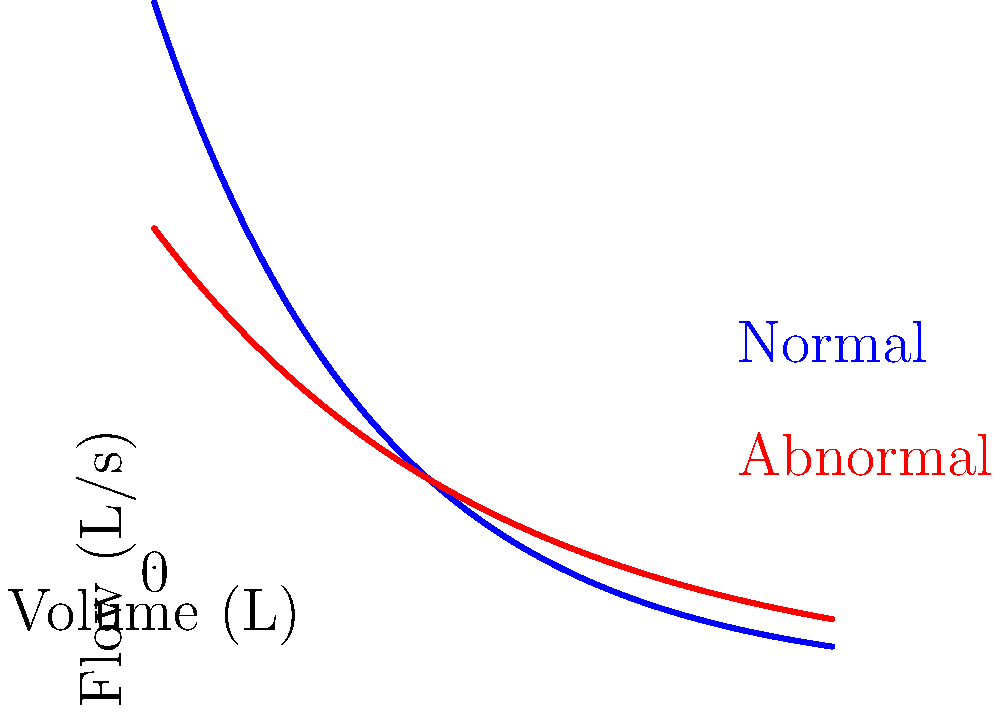Based on the spirometry graph shown, which represents a flow-volume loop for both a normal subject (blue) and a patient with lung dysfunction (red), what type of lung condition does the abnormal curve most likely indicate? To interpret this spirometry graph and identify the likely lung condition:

1. Observe the shape of both curves:
   - The normal curve (blue) shows a rapid rise to peak flow, followed by a steady decline.
   - The abnormal curve (red) shows a lower peak flow and a more gradual decline.

2. Compare the expiratory flow rates:
   - The abnormal curve has lower flow rates throughout expiration.
   - The peak expiratory flow (PEF) is significantly reduced in the abnormal curve.

3. Analyze the shape of the expiratory phase:
   - The abnormal curve shows a more concave shape compared to the normal curve.
   - This indicates increased airway resistance and difficulty exhaling.

4. Consider the volume axis:
   - The abnormal curve reaches a slightly lower total volume, suggesting reduced lung capacity.

5. Evaluate the overall pattern:
   - The combination of reduced PEF, concave expiratory curve, and lower flow rates throughout expiration is characteristic of obstructive lung diseases.

6. Match the pattern to known conditions:
   - These findings are consistent with conditions like chronic obstructive pulmonary disease (COPD) or asthma.
   - However, the persistent nature of the obstruction throughout the expiratory phase is more indicative of COPD.

Given these observations and the persona of an active senior with minor ailments, the most likely condition represented by the abnormal curve is COPD.
Answer: Chronic Obstructive Pulmonary Disease (COPD) 